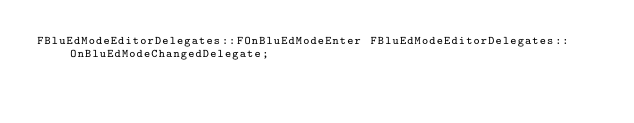Convert code to text. <code><loc_0><loc_0><loc_500><loc_500><_C++_>FBluEdModeEditorDelegates::FOnBluEdModeEnter FBluEdModeEditorDelegates::OnBluEdModeChangedDelegate;
</code> 